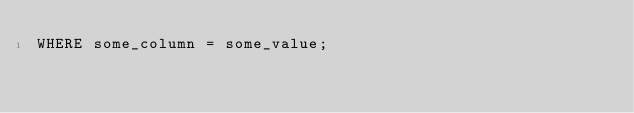Convert code to text. <code><loc_0><loc_0><loc_500><loc_500><_SQL_>WHERE some_column = some_value;</code> 